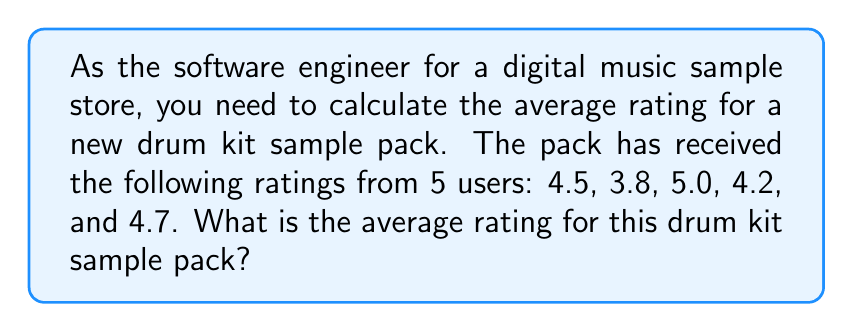Can you answer this question? To calculate the average rating, we need to follow these steps:

1. Sum up all the ratings:
   $4.5 + 3.8 + 5.0 + 4.2 + 4.7 = 22.2$

2. Count the total number of ratings:
   There are 5 ratings in total.

3. Divide the sum by the total number of ratings:
   $\text{Average} = \frac{\text{Sum of ratings}}{\text{Number of ratings}}$

   $\text{Average} = \frac{22.2}{5}$

4. Perform the division:
   $\text{Average} = 4.44$

Therefore, the average rating for the drum kit sample pack is 4.44 out of 5.
Answer: 4.44 